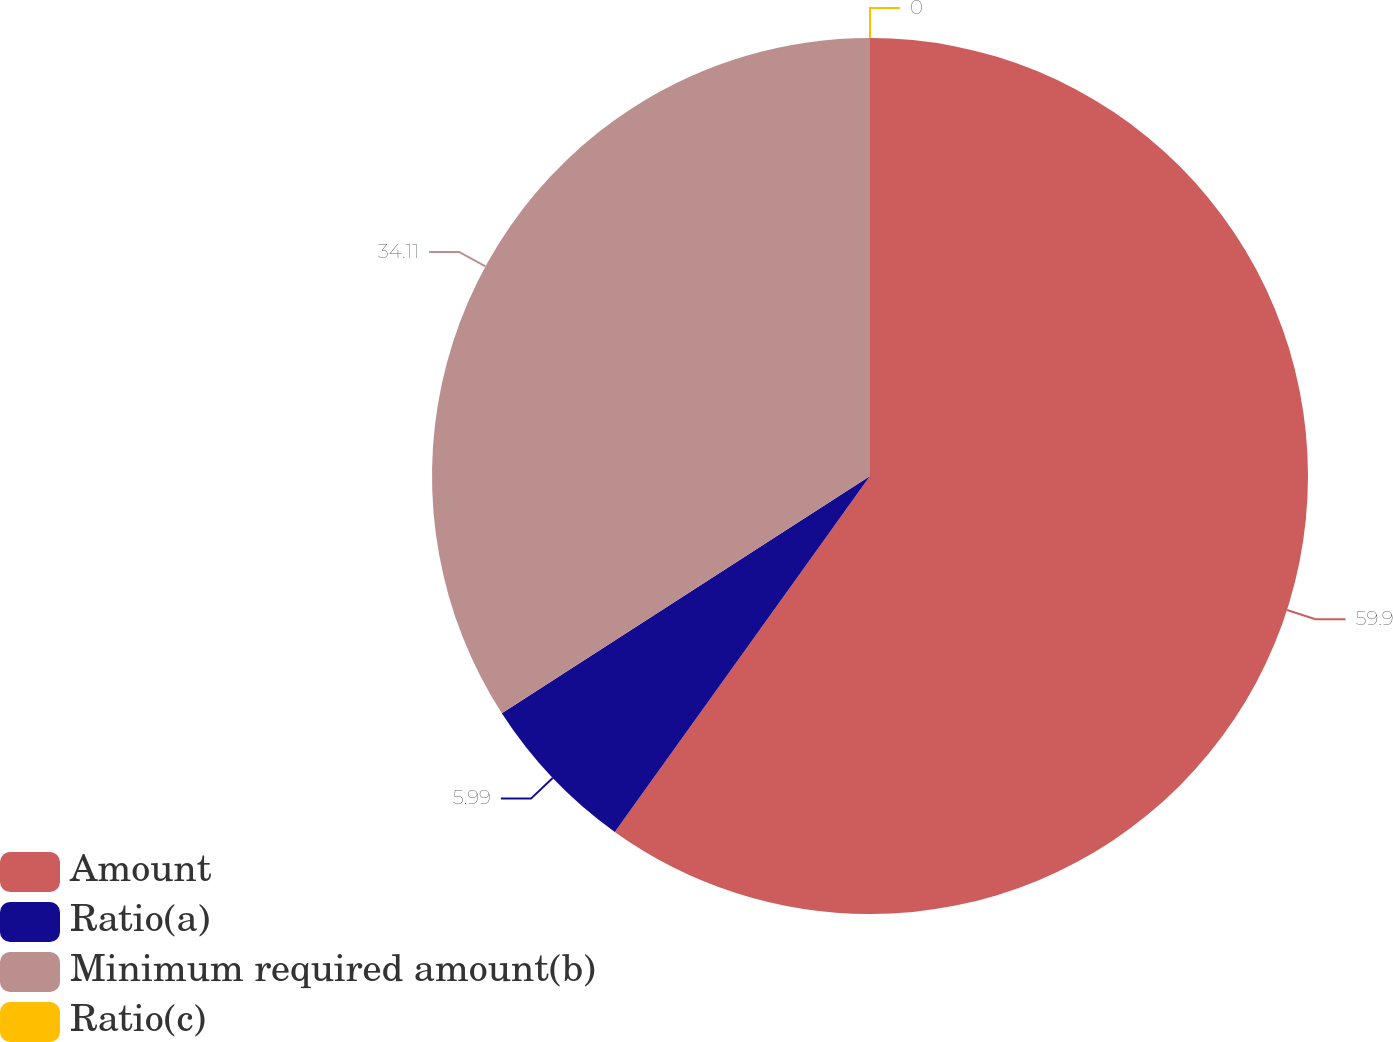Convert chart to OTSL. <chart><loc_0><loc_0><loc_500><loc_500><pie_chart><fcel>Amount<fcel>Ratio(a)<fcel>Minimum required amount(b)<fcel>Ratio(c)<nl><fcel>59.9%<fcel>5.99%<fcel>34.11%<fcel>0.0%<nl></chart> 